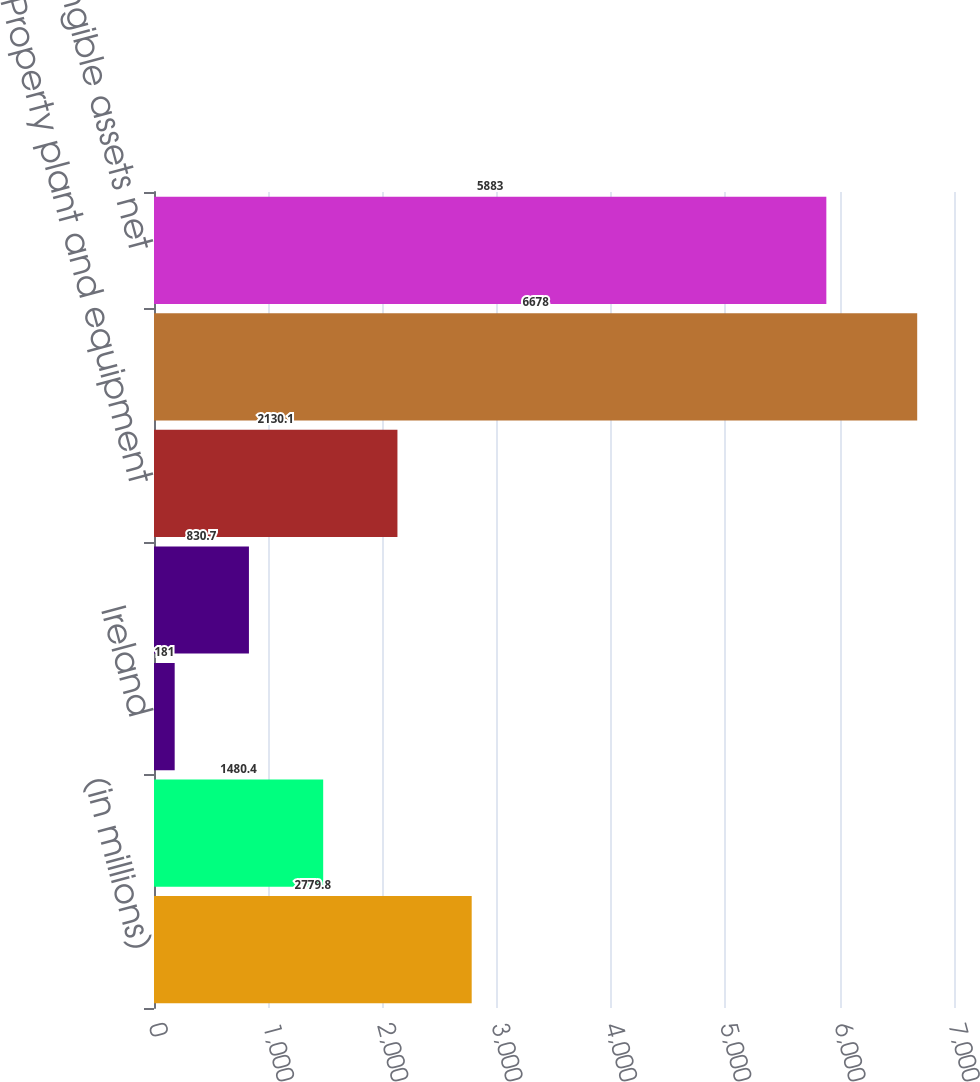<chart> <loc_0><loc_0><loc_500><loc_500><bar_chart><fcel>(in millions)<fcel>United States<fcel>Ireland<fcel>Other countries<fcel>Property plant and equipment<fcel>Goodwill<fcel>Other intangible assets net<nl><fcel>2779.8<fcel>1480.4<fcel>181<fcel>830.7<fcel>2130.1<fcel>6678<fcel>5883<nl></chart> 